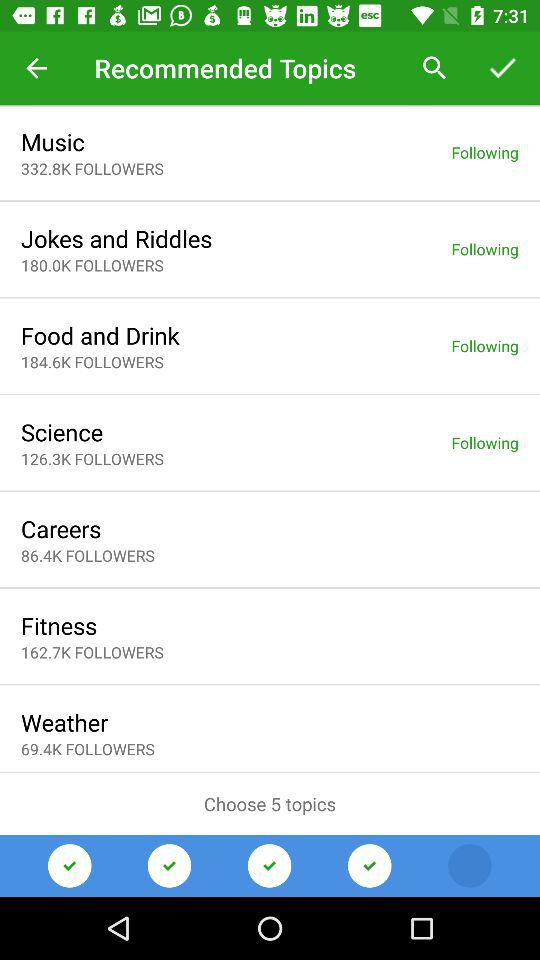What is the total number of followers for "Music"? The total number of followers is 332.8K. 